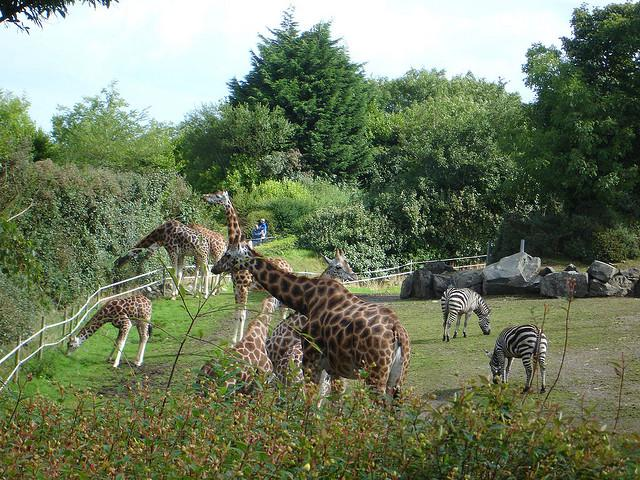How many different species of animals are grazing in the savannah? two 